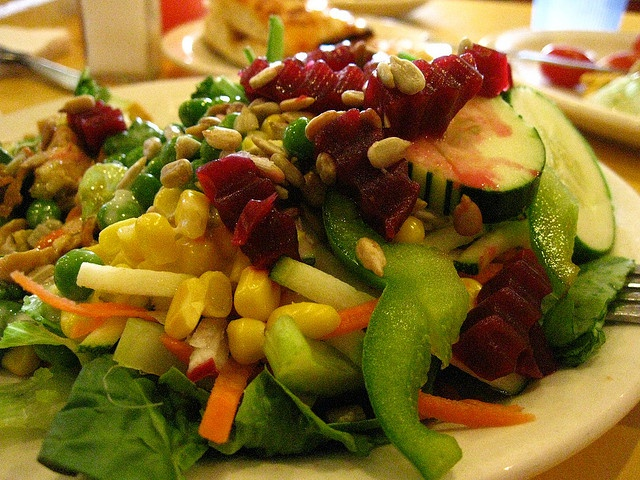Describe the objects in this image and their specific colors. I can see dining table in black, olive, and maroon tones, carrot in tan, red, brown, and maroon tones, carrot in tan, brown, red, and black tones, carrot in tan, red, orange, and brown tones, and fork in tan, olive, and black tones in this image. 